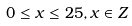Convert formula to latex. <formula><loc_0><loc_0><loc_500><loc_500>0 \leq x \leq 2 5 , x \in Z</formula> 